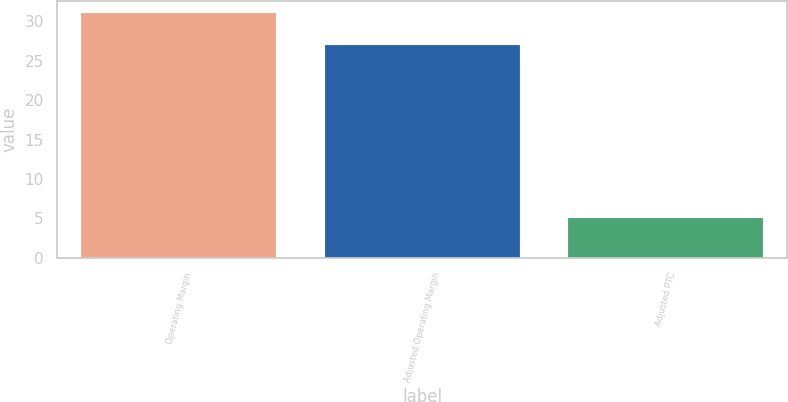<chart> <loc_0><loc_0><loc_500><loc_500><bar_chart><fcel>Operating Margin<fcel>Adjusted Operating Margin<fcel>Adjusted PTC<nl><fcel>31<fcel>27<fcel>5<nl></chart> 